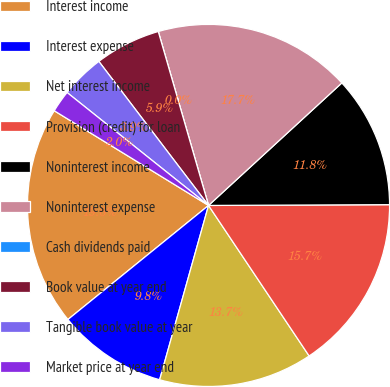Convert chart. <chart><loc_0><loc_0><loc_500><loc_500><pie_chart><fcel>Interest income<fcel>Interest expense<fcel>Net interest income<fcel>Provision (credit) for loan<fcel>Noninterest income<fcel>Noninterest expense<fcel>Cash dividends paid<fcel>Book value at year end<fcel>Tangible book value at year<fcel>Market price at year end<nl><fcel>19.61%<fcel>9.8%<fcel>13.73%<fcel>15.69%<fcel>11.76%<fcel>17.65%<fcel>0.0%<fcel>5.88%<fcel>3.92%<fcel>1.96%<nl></chart> 